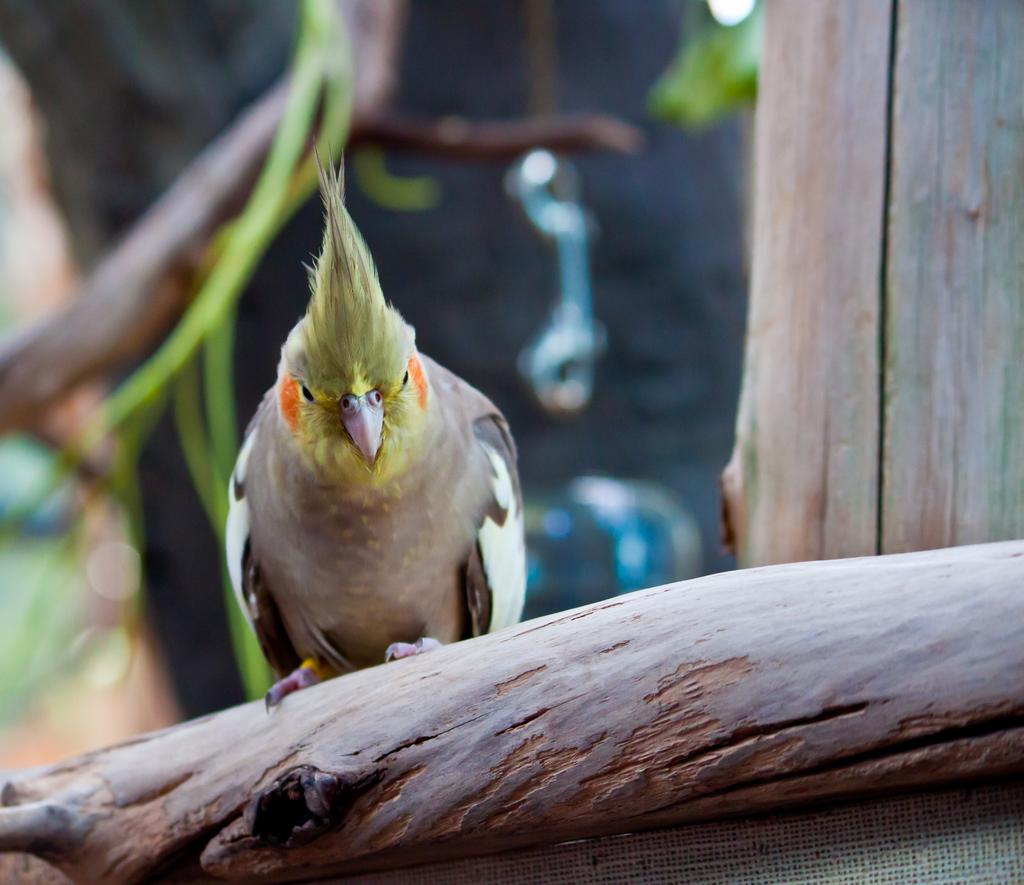What animal is in the foreground of the picture? There is a parrot in the foreground of the picture. Where is the parrot located? The parrot is on the trunk of a tree. Can you describe the tree in the image? There is a trunk on the right side of the image. How would you describe the background of the image? The background of the image is blurred. How many chickens are visible in the image? There are no chickens present in the image. Are there any lizards crawling on the tree trunk in the image? There are no lizards visible in the image. 